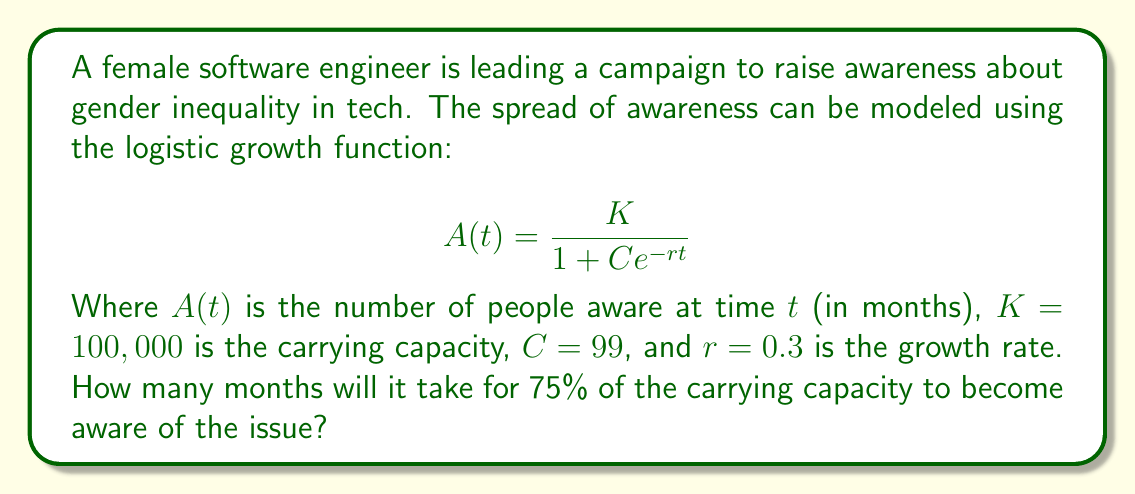Provide a solution to this math problem. To solve this problem, we'll follow these steps:

1) We need to find $t$ when $A(t) = 0.75K = 75,000$.

2) Substitute the known values into the logistic growth equation:

   $$75,000 = \frac{100,000}{1 + 99e^{-0.3t}}$$

3) Simplify:

   $$0.75 = \frac{1}{1 + 99e^{-0.3t}}$$

4) Take the reciprocal of both sides:

   $$\frac{4}{3} = 1 + 99e^{-0.3t}$$

5) Subtract 1 from both sides:

   $$\frac{1}{3} = 99e^{-0.3t}$$

6) Divide both sides by 99:

   $$\frac{1}{297} = e^{-0.3t}$$

7) Take the natural logarithm of both sides:

   $$\ln(\frac{1}{297}) = -0.3t$$

8) Solve for $t$:

   $$t = -\frac{\ln(\frac{1}{297})}{0.3} = \frac{\ln(297)}{0.3}$$

9) Calculate the final result:

   $$t \approx 19.07$$

Therefore, it will take approximately 19.07 months for 75% of the carrying capacity to become aware of the gender inequality issue in tech.
Answer: $19.07$ months 